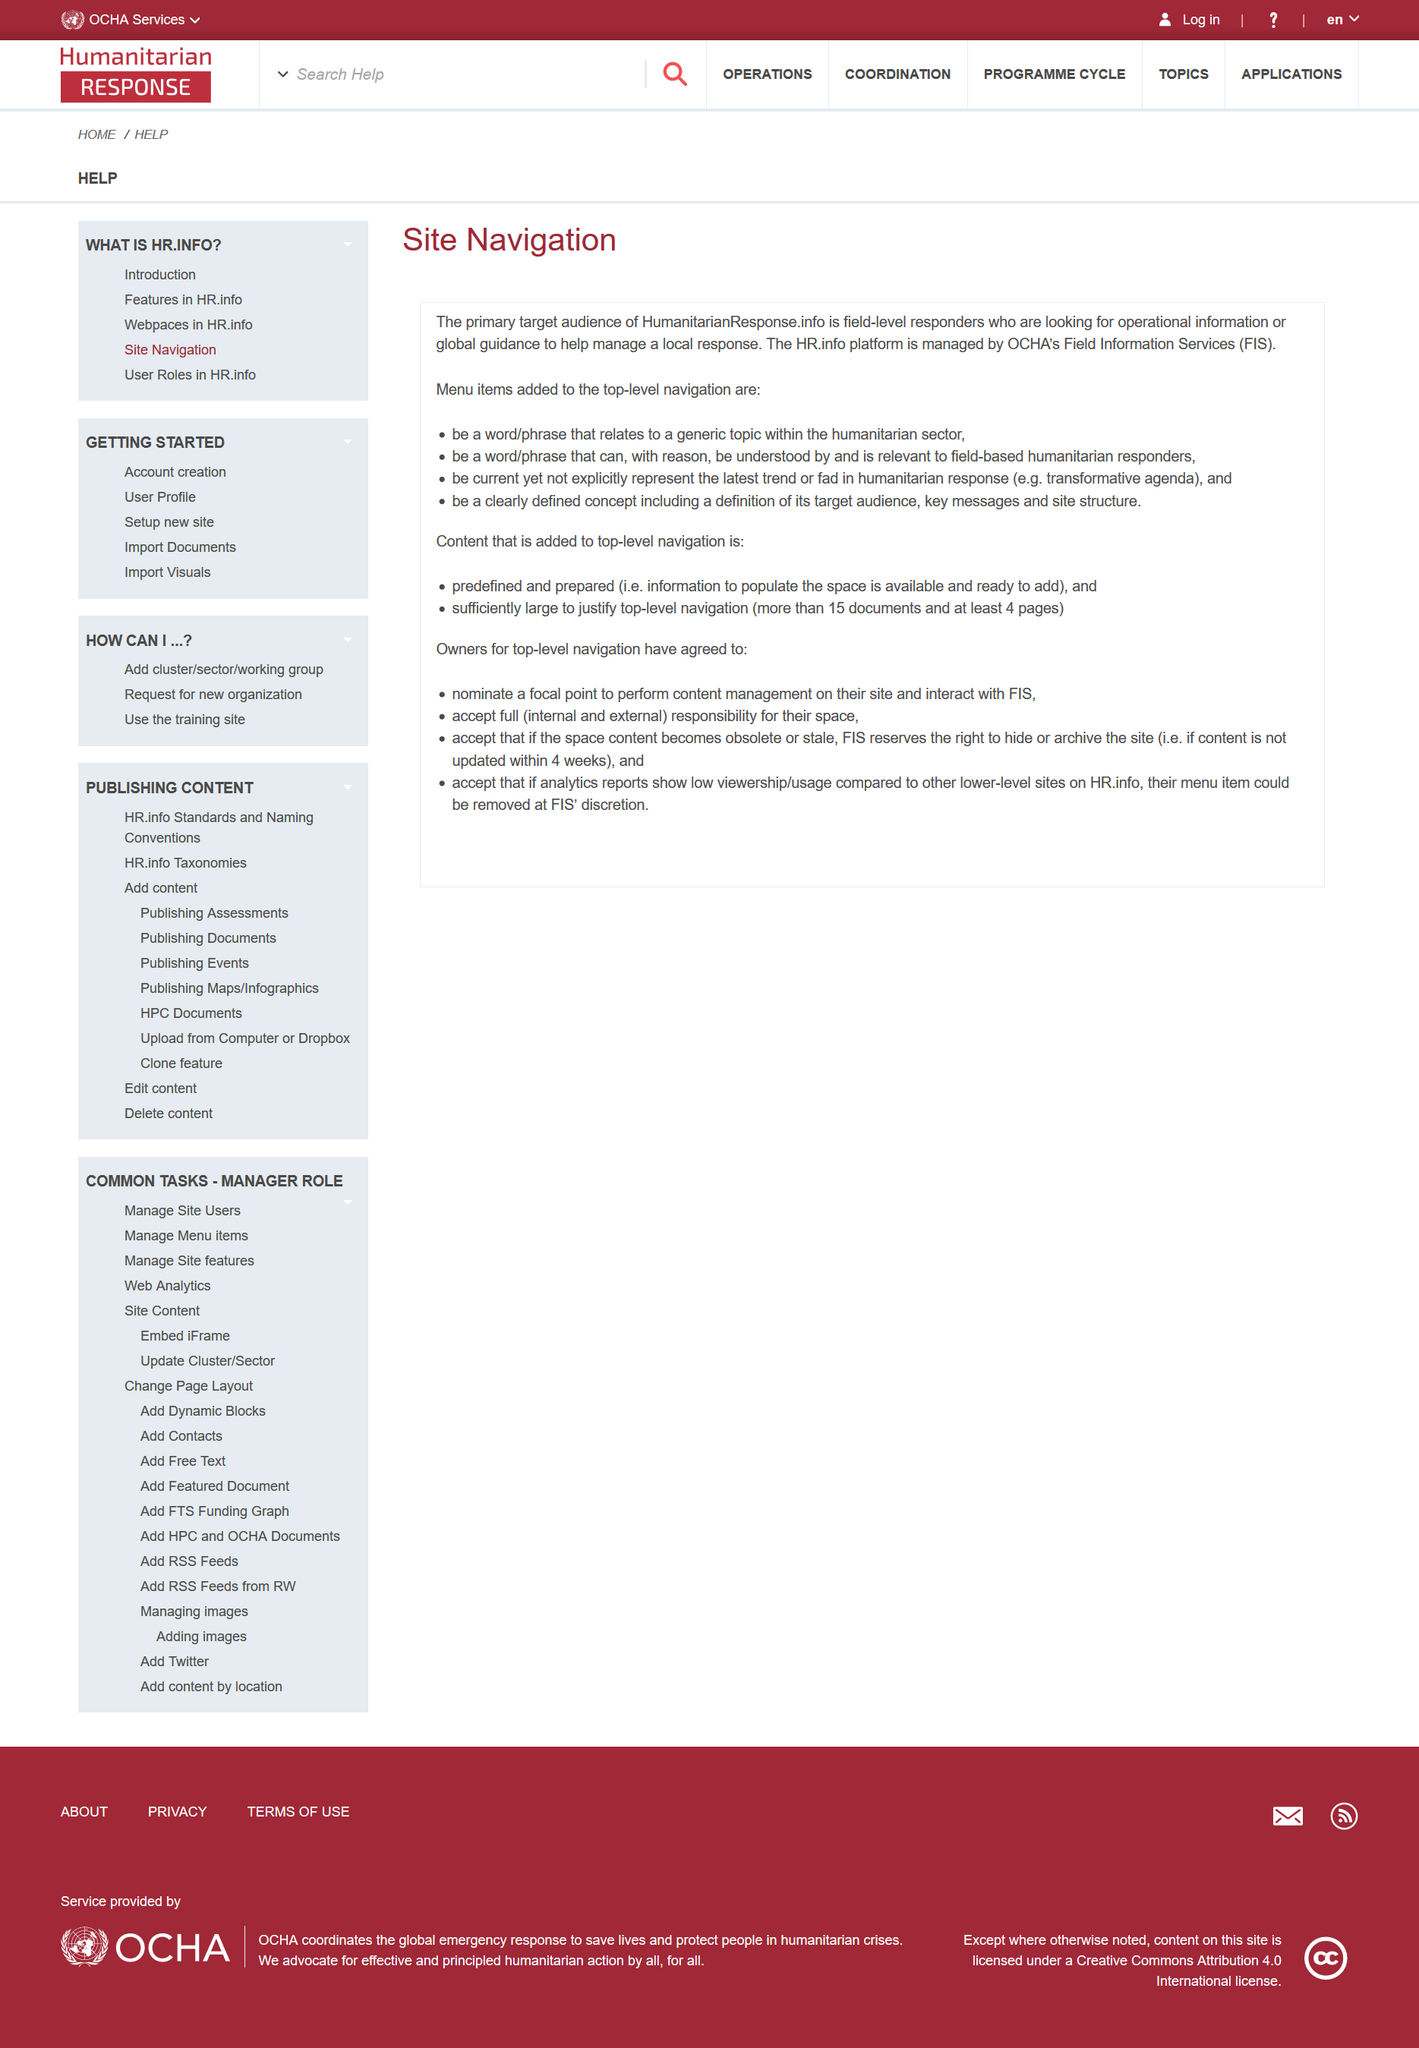Mention a couple of crucial points in this snapshot. The addition of a word/phrase relating to a generic topic within the humanitarian sector to the top-level navigation of the site has been confirmed. Field Information Services is an acronym that stands for the provision of data and information related to specific fields or areas of expertise. Field-level responders are the primary target audience for HumanitarianResponse.info. 